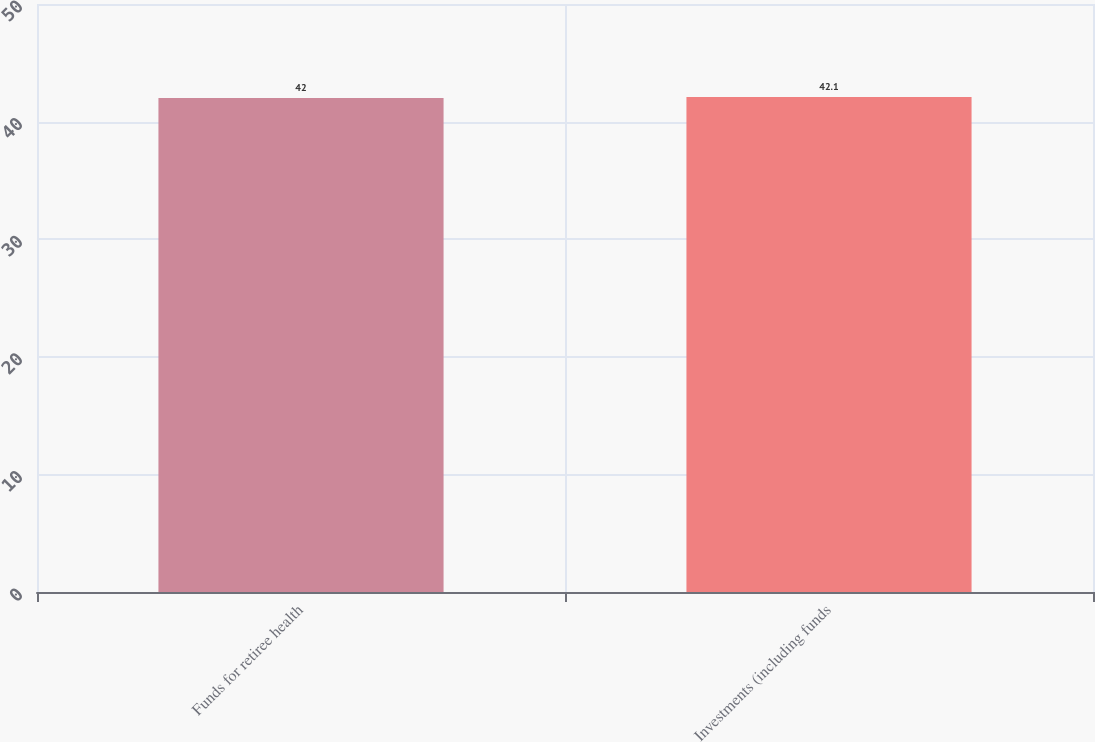Convert chart to OTSL. <chart><loc_0><loc_0><loc_500><loc_500><bar_chart><fcel>Funds for retiree health<fcel>Investments (including funds<nl><fcel>42<fcel>42.1<nl></chart> 